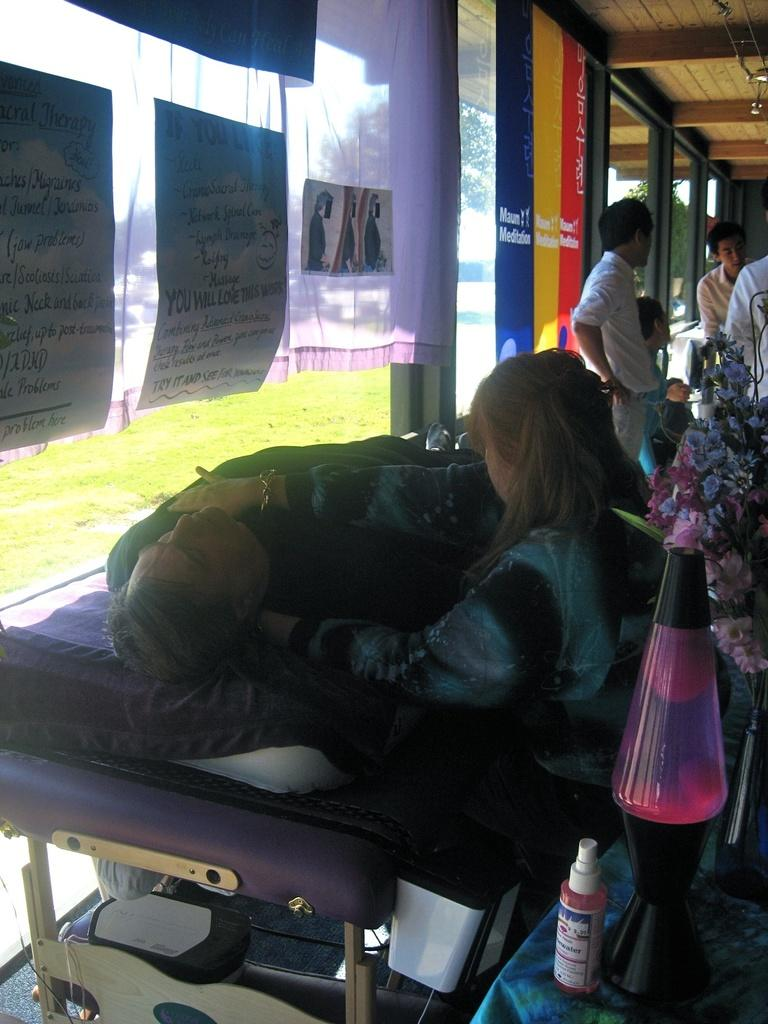How many people are in the image? There are people in the image, but the exact number is not specified. What is the man in the image doing? The man is lying on a bed in the image. What can be seen in the image besides the people and the man on the bed? There is a bottle and other objects visible in the image. What is in the background of the image? In the background of the image, there are curtains, a window, and grass visible. What type of ticket is the man holding in the image? There is no ticket present in the image. What is the man's income based on the image? There is no information about the man's income in the image. 